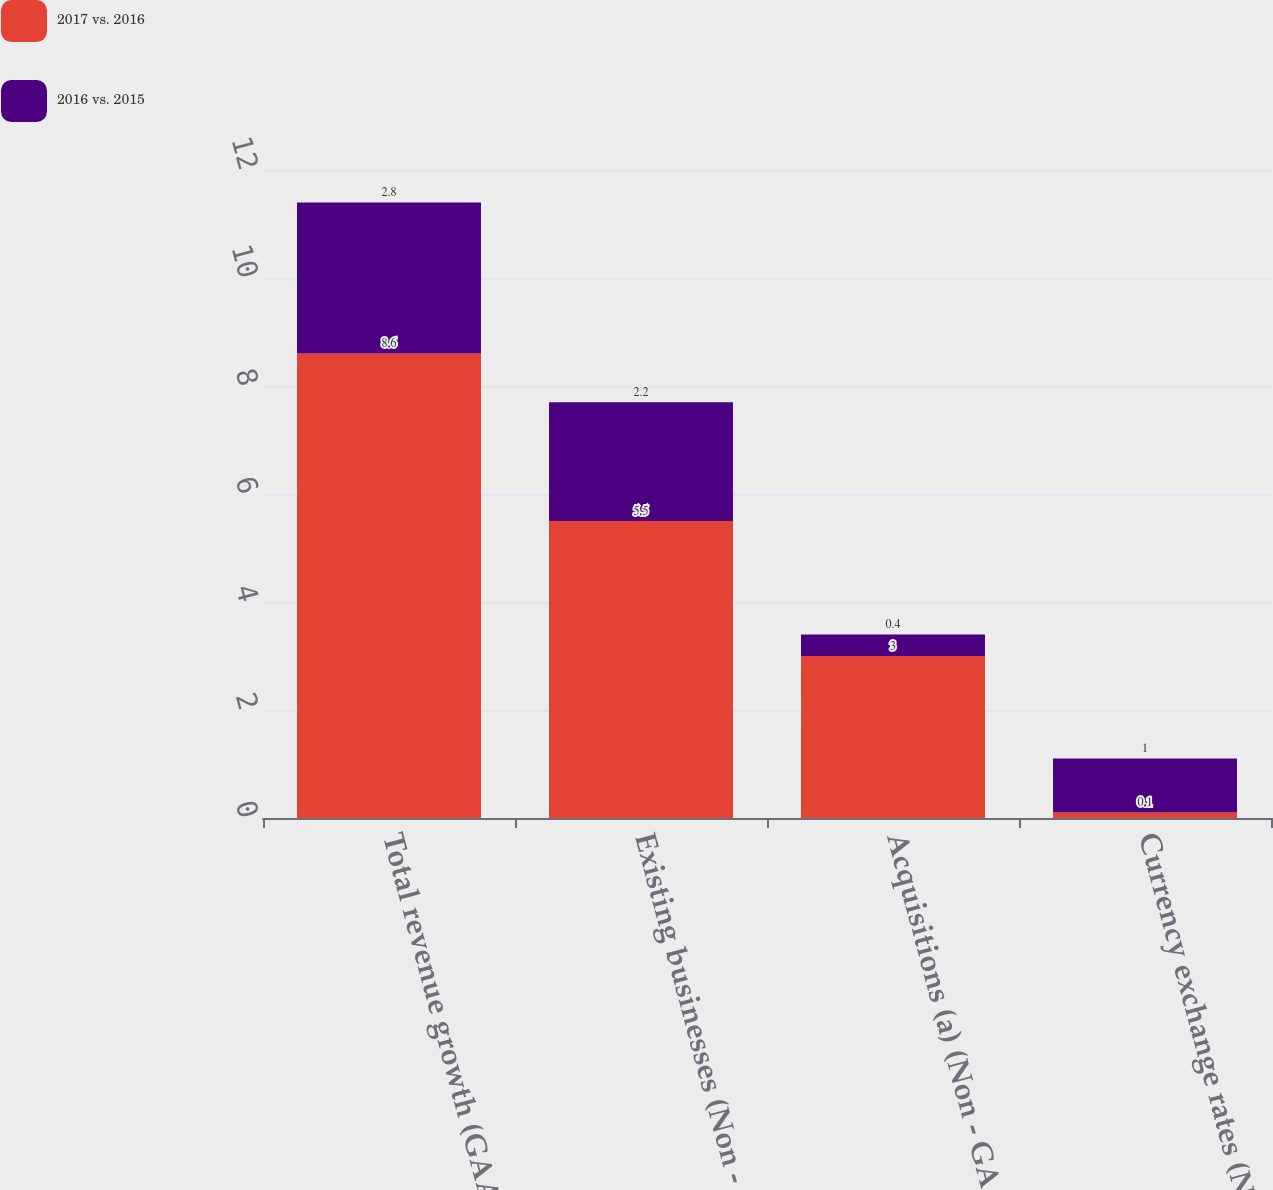Convert chart. <chart><loc_0><loc_0><loc_500><loc_500><stacked_bar_chart><ecel><fcel>Total revenue growth (GAAP)<fcel>Existing businesses (Non -<fcel>Acquisitions (a) (Non - GAAP)<fcel>Currency exchange rates (Non -<nl><fcel>2017 vs. 2016<fcel>8.6<fcel>5.5<fcel>3<fcel>0.1<nl><fcel>2016 vs. 2015<fcel>2.8<fcel>2.2<fcel>0.4<fcel>1<nl></chart> 